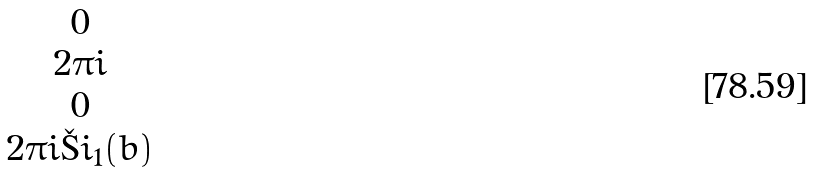Convert formula to latex. <formula><loc_0><loc_0><loc_500><loc_500>\begin{matrix} 0 \\ 2 \pi i \\ 0 \\ 2 \pi i \L i _ { 1 } ( b ) \end{matrix}</formula> 